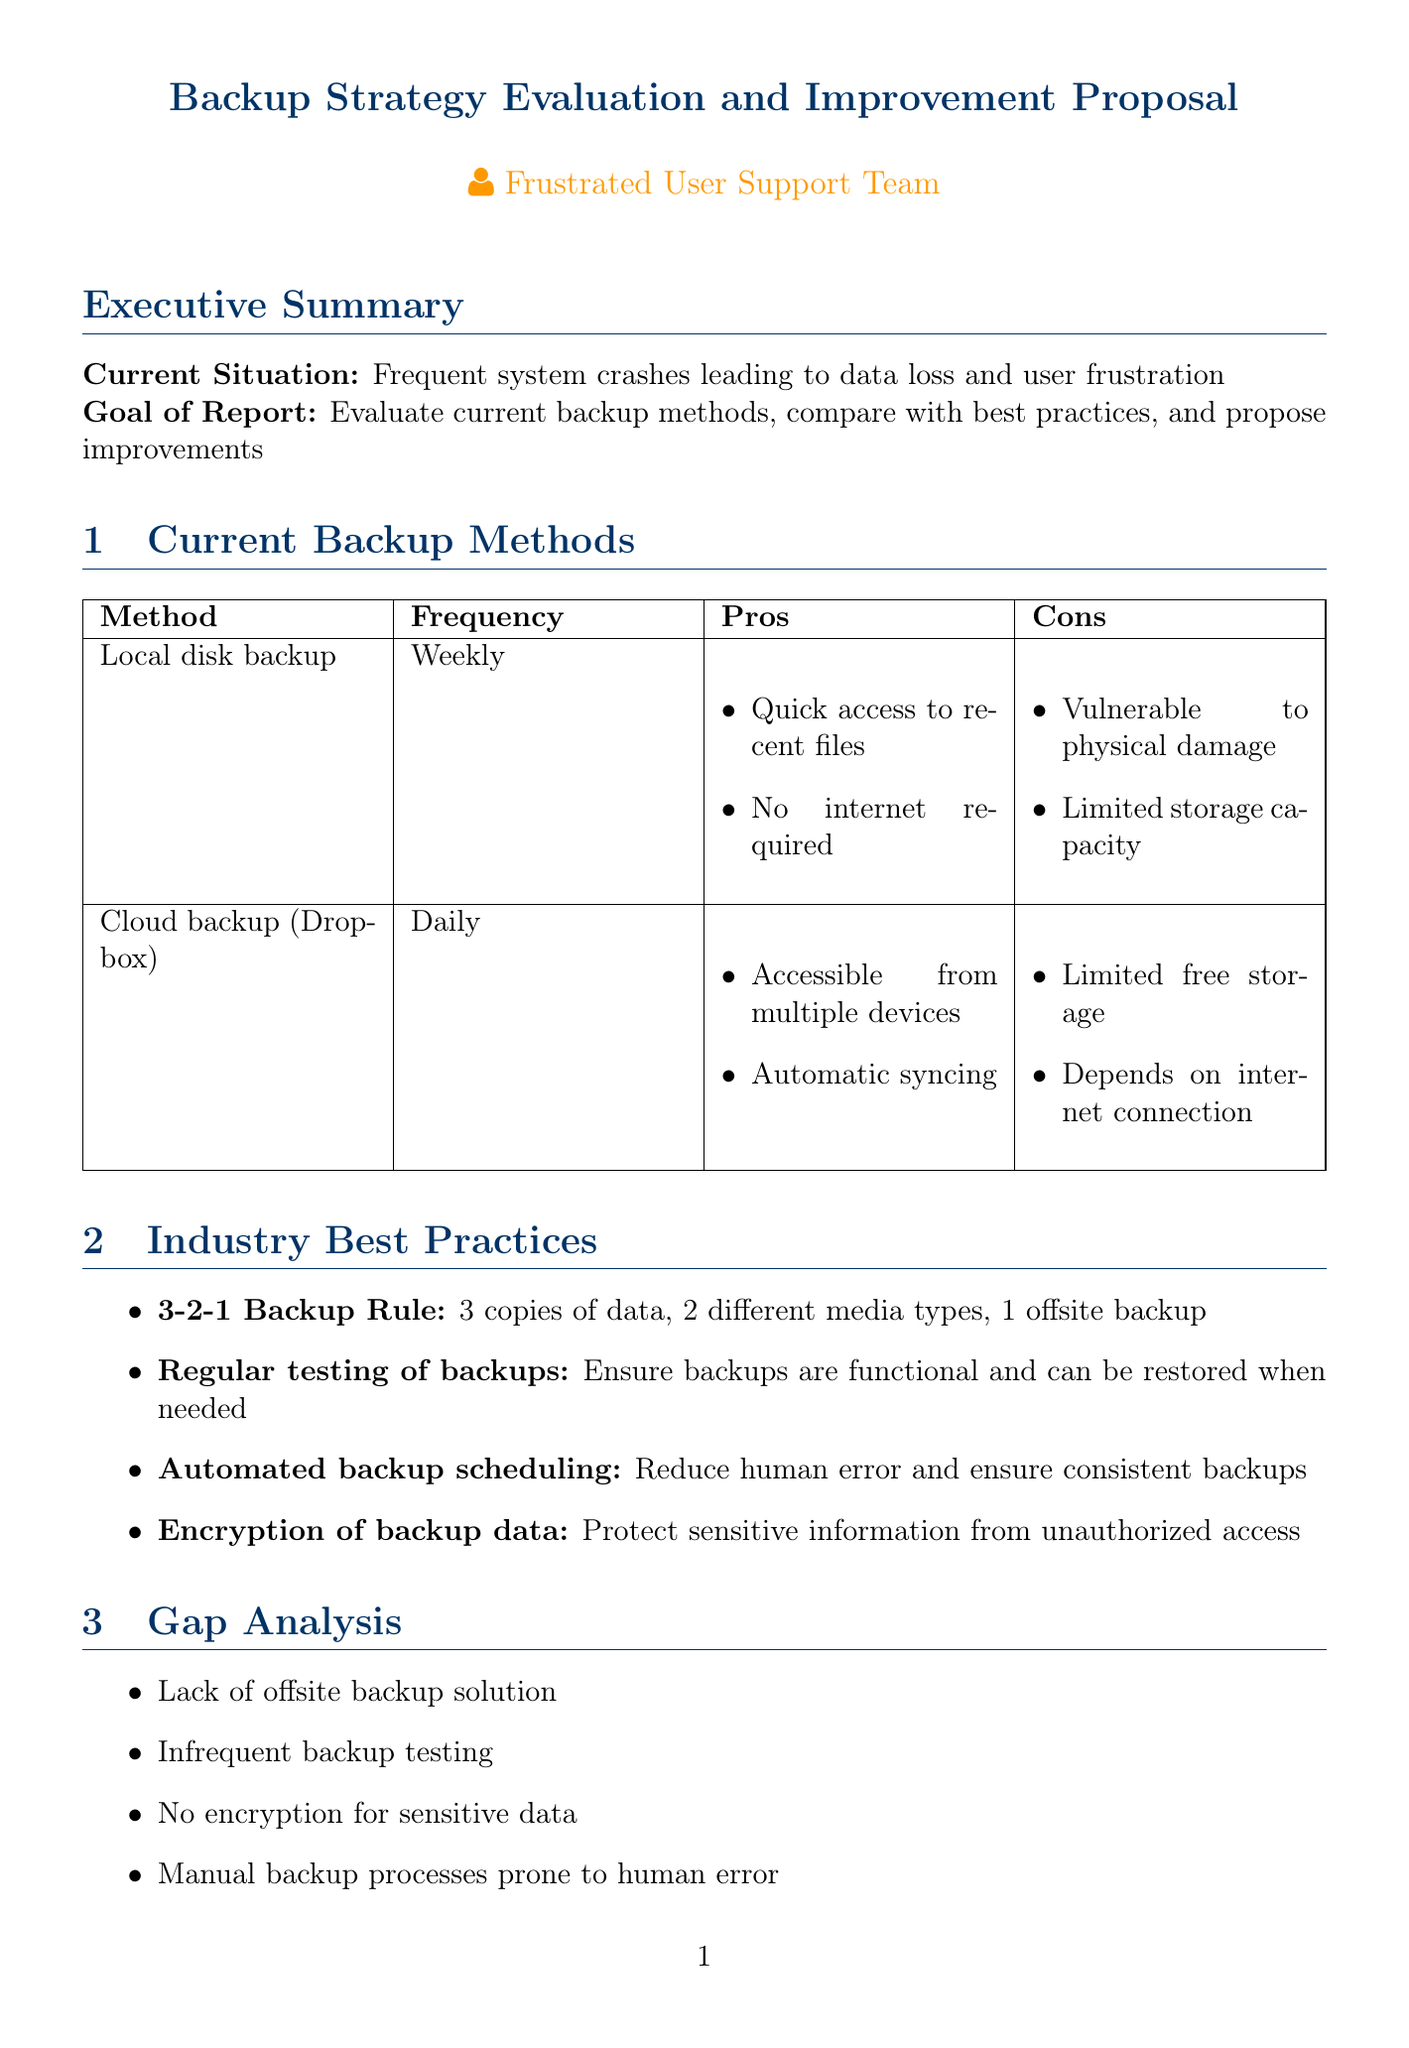What are the current backup methods? The document lists two current backup methods: Local disk backup and Cloud backup using Dropbox.
Answer: Local disk backup, Cloud backup using Dropbox What is the frequency of the local disk backup? The document specifies that the local disk backup is performed weekly.
Answer: Weekly What is the first improvement proposed? The first improvement suggested in the document is Implement Backblaze B2 Cloud Storage.
Answer: Implement Backblaze B2 Cloud Storage What does the 3-2-1 backup rule entail? The document describes the 3-2-1 backup rule as having 3 copies of data, 2 different media types, and 1 offsite backup.
Answer: 3 copies of data, 2 different media types, 1 offsite backup What is the estimated potential savings from the proposed improvements? According to the document, the reduction in downtime and data loss could save an estimated $10,000 per year.
Answer: $10,000 per year Why is encryption of backup data important? The document states that encryption of backup data is crucial to protect sensitive information from unauthorized access.
Answer: Protect sensitive information from unauthorized access What phase involves training IT staff? The implementation phase includes training IT staff on new backup and restore procedures.
Answer: Implementation How often should backup restore tests be implemented? The document suggests implementing monthly backup restore tests to ensure data recoverability.
Answer: Monthly 